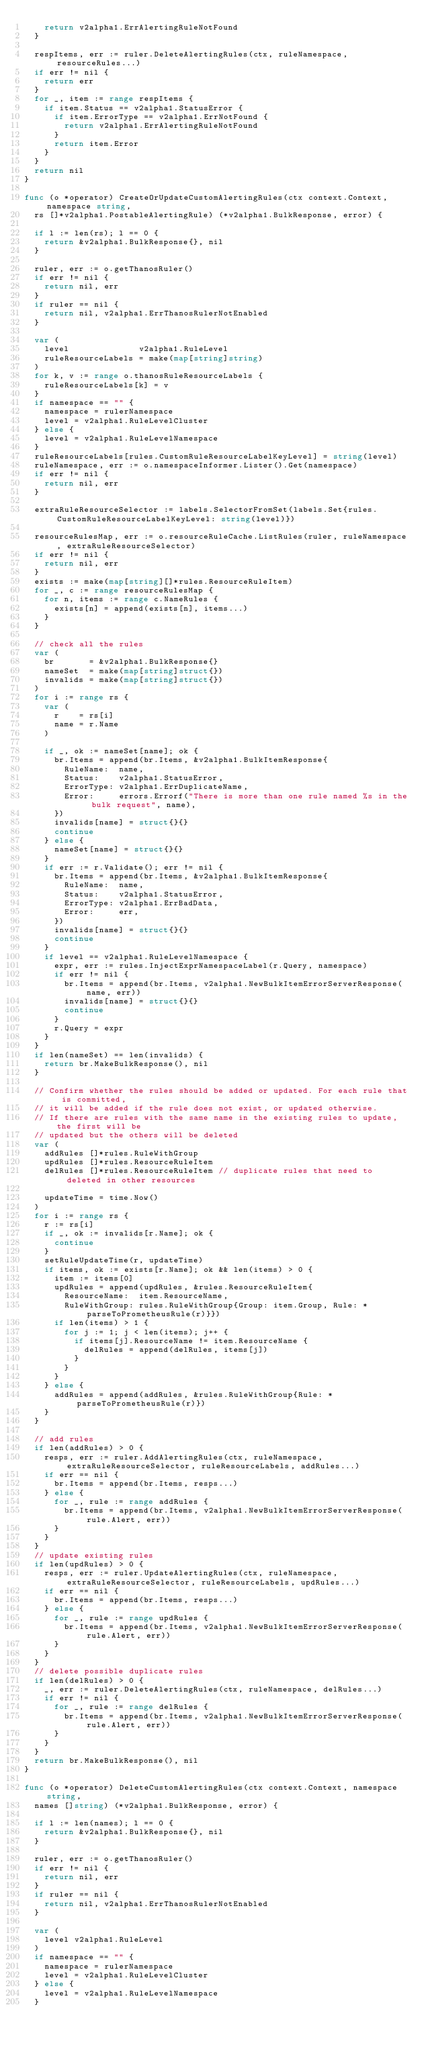Convert code to text. <code><loc_0><loc_0><loc_500><loc_500><_Go_>		return v2alpha1.ErrAlertingRuleNotFound
	}

	respItems, err := ruler.DeleteAlertingRules(ctx, ruleNamespace, resourceRules...)
	if err != nil {
		return err
	}
	for _, item := range respItems {
		if item.Status == v2alpha1.StatusError {
			if item.ErrorType == v2alpha1.ErrNotFound {
				return v2alpha1.ErrAlertingRuleNotFound
			}
			return item.Error
		}
	}
	return nil
}

func (o *operator) CreateOrUpdateCustomAlertingRules(ctx context.Context, namespace string,
	rs []*v2alpha1.PostableAlertingRule) (*v2alpha1.BulkResponse, error) {

	if l := len(rs); l == 0 {
		return &v2alpha1.BulkResponse{}, nil
	}

	ruler, err := o.getThanosRuler()
	if err != nil {
		return nil, err
	}
	if ruler == nil {
		return nil, v2alpha1.ErrThanosRulerNotEnabled
	}

	var (
		level              v2alpha1.RuleLevel
		ruleResourceLabels = make(map[string]string)
	)
	for k, v := range o.thanosRuleResourceLabels {
		ruleResourceLabels[k] = v
	}
	if namespace == "" {
		namespace = rulerNamespace
		level = v2alpha1.RuleLevelCluster
	} else {
		level = v2alpha1.RuleLevelNamespace
	}
	ruleResourceLabels[rules.CustomRuleResourceLabelKeyLevel] = string(level)
	ruleNamespace, err := o.namespaceInformer.Lister().Get(namespace)
	if err != nil {
		return nil, err
	}

	extraRuleResourceSelector := labels.SelectorFromSet(labels.Set{rules.CustomRuleResourceLabelKeyLevel: string(level)})

	resourceRulesMap, err := o.resourceRuleCache.ListRules(ruler, ruleNamespace, extraRuleResourceSelector)
	if err != nil {
		return nil, err
	}
	exists := make(map[string][]*rules.ResourceRuleItem)
	for _, c := range resourceRulesMap {
		for n, items := range c.NameRules {
			exists[n] = append(exists[n], items...)
		}
	}

	// check all the rules
	var (
		br       = &v2alpha1.BulkResponse{}
		nameSet  = make(map[string]struct{})
		invalids = make(map[string]struct{})
	)
	for i := range rs {
		var (
			r    = rs[i]
			name = r.Name
		)

		if _, ok := nameSet[name]; ok {
			br.Items = append(br.Items, &v2alpha1.BulkItemResponse{
				RuleName:  name,
				Status:    v2alpha1.StatusError,
				ErrorType: v2alpha1.ErrDuplicateName,
				Error:     errors.Errorf("There is more than one rule named %s in the bulk request", name),
			})
			invalids[name] = struct{}{}
			continue
		} else {
			nameSet[name] = struct{}{}
		}
		if err := r.Validate(); err != nil {
			br.Items = append(br.Items, &v2alpha1.BulkItemResponse{
				RuleName:  name,
				Status:    v2alpha1.StatusError,
				ErrorType: v2alpha1.ErrBadData,
				Error:     err,
			})
			invalids[name] = struct{}{}
			continue
		}
		if level == v2alpha1.RuleLevelNamespace {
			expr, err := rules.InjectExprNamespaceLabel(r.Query, namespace)
			if err != nil {
				br.Items = append(br.Items, v2alpha1.NewBulkItemErrorServerResponse(name, err))
				invalids[name] = struct{}{}
				continue
			}
			r.Query = expr
		}
	}
	if len(nameSet) == len(invalids) {
		return br.MakeBulkResponse(), nil
	}

	// Confirm whether the rules should be added or updated. For each rule that is committed,
	// it will be added if the rule does not exist, or updated otherwise.
	// If there are rules with the same name in the existing rules to update, the first will be
	// updated but the others will be deleted
	var (
		addRules []*rules.RuleWithGroup
		updRules []*rules.ResourceRuleItem
		delRules []*rules.ResourceRuleItem // duplicate rules that need to deleted in other resources

		updateTime = time.Now()
	)
	for i := range rs {
		r := rs[i]
		if _, ok := invalids[r.Name]; ok {
			continue
		}
		setRuleUpdateTime(r, updateTime)
		if items, ok := exists[r.Name]; ok && len(items) > 0 {
			item := items[0]
			updRules = append(updRules, &rules.ResourceRuleItem{
				ResourceName:  item.ResourceName,
				RuleWithGroup: rules.RuleWithGroup{Group: item.Group, Rule: *parseToPrometheusRule(r)}})
			if len(items) > 1 {
				for j := 1; j < len(items); j++ {
					if items[j].ResourceName != item.ResourceName {
						delRules = append(delRules, items[j])
					}
				}
			}
		} else {
			addRules = append(addRules, &rules.RuleWithGroup{Rule: *parseToPrometheusRule(r)})
		}
	}

	// add rules
	if len(addRules) > 0 {
		resps, err := ruler.AddAlertingRules(ctx, ruleNamespace, extraRuleResourceSelector, ruleResourceLabels, addRules...)
		if err == nil {
			br.Items = append(br.Items, resps...)
		} else {
			for _, rule := range addRules {
				br.Items = append(br.Items, v2alpha1.NewBulkItemErrorServerResponse(rule.Alert, err))
			}
		}
	}
	// update existing rules
	if len(updRules) > 0 {
		resps, err := ruler.UpdateAlertingRules(ctx, ruleNamespace, extraRuleResourceSelector, ruleResourceLabels, updRules...)
		if err == nil {
			br.Items = append(br.Items, resps...)
		} else {
			for _, rule := range updRules {
				br.Items = append(br.Items, v2alpha1.NewBulkItemErrorServerResponse(rule.Alert, err))
			}
		}
	}
	// delete possible duplicate rules
	if len(delRules) > 0 {
		_, err := ruler.DeleteAlertingRules(ctx, ruleNamespace, delRules...)
		if err != nil {
			for _, rule := range delRules {
				br.Items = append(br.Items, v2alpha1.NewBulkItemErrorServerResponse(rule.Alert, err))
			}
		}
	}
	return br.MakeBulkResponse(), nil
}

func (o *operator) DeleteCustomAlertingRules(ctx context.Context, namespace string,
	names []string) (*v2alpha1.BulkResponse, error) {

	if l := len(names); l == 0 {
		return &v2alpha1.BulkResponse{}, nil
	}

	ruler, err := o.getThanosRuler()
	if err != nil {
		return nil, err
	}
	if ruler == nil {
		return nil, v2alpha1.ErrThanosRulerNotEnabled
	}

	var (
		level v2alpha1.RuleLevel
	)
	if namespace == "" {
		namespace = rulerNamespace
		level = v2alpha1.RuleLevelCluster
	} else {
		level = v2alpha1.RuleLevelNamespace
	}</code> 